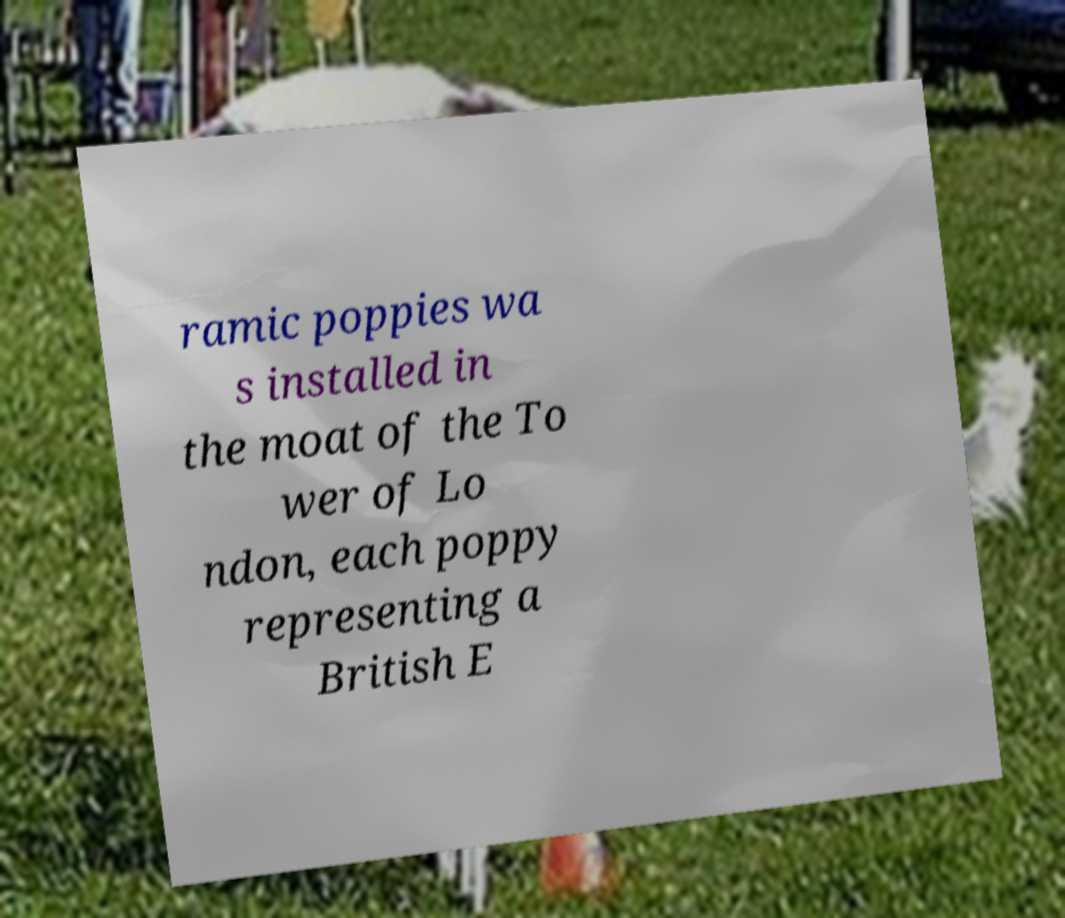What messages or text are displayed in this image? I need them in a readable, typed format. ramic poppies wa s installed in the moat of the To wer of Lo ndon, each poppy representing a British E 